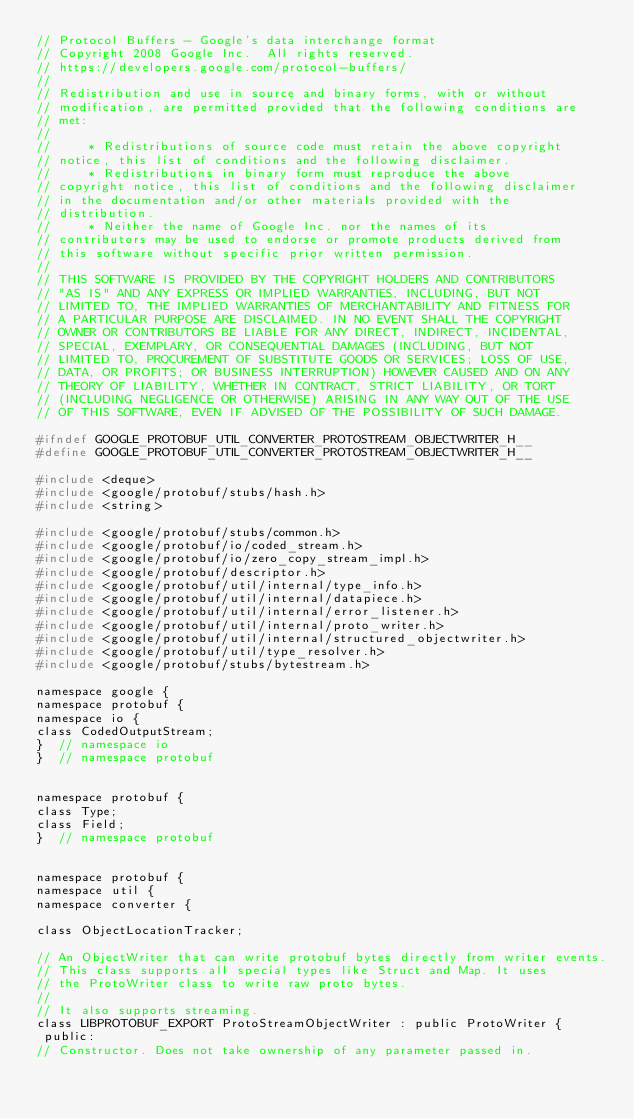Convert code to text. <code><loc_0><loc_0><loc_500><loc_500><_C_>// Protocol Buffers - Google's data interchange format
// Copyright 2008 Google Inc.  All rights reserved.
// https://developers.google.com/protocol-buffers/
//
// Redistribution and use in source and binary forms, with or without
// modification, are permitted provided that the following conditions are
// met:
//
//     * Redistributions of source code must retain the above copyright
// notice, this list of conditions and the following disclaimer.
//     * Redistributions in binary form must reproduce the above
// copyright notice, this list of conditions and the following disclaimer
// in the documentation and/or other materials provided with the
// distribution.
//     * Neither the name of Google Inc. nor the names of its
// contributors may be used to endorse or promote products derived from
// this software without specific prior written permission.
//
// THIS SOFTWARE IS PROVIDED BY THE COPYRIGHT HOLDERS AND CONTRIBUTORS
// "AS IS" AND ANY EXPRESS OR IMPLIED WARRANTIES, INCLUDING, BUT NOT
// LIMITED TO, THE IMPLIED WARRANTIES OF MERCHANTABILITY AND FITNESS FOR
// A PARTICULAR PURPOSE ARE DISCLAIMED. IN NO EVENT SHALL THE COPYRIGHT
// OWNER OR CONTRIBUTORS BE LIABLE FOR ANY DIRECT, INDIRECT, INCIDENTAL,
// SPECIAL, EXEMPLARY, OR CONSEQUENTIAL DAMAGES (INCLUDING, BUT NOT
// LIMITED TO, PROCUREMENT OF SUBSTITUTE GOODS OR SERVICES; LOSS OF USE,
// DATA, OR PROFITS; OR BUSINESS INTERRUPTION) HOWEVER CAUSED AND ON ANY
// THEORY OF LIABILITY, WHETHER IN CONTRACT, STRICT LIABILITY, OR TORT
// (INCLUDING NEGLIGENCE OR OTHERWISE) ARISING IN ANY WAY OUT OF THE USE
// OF THIS SOFTWARE, EVEN IF ADVISED OF THE POSSIBILITY OF SUCH DAMAGE.

#ifndef GOOGLE_PROTOBUF_UTIL_CONVERTER_PROTOSTREAM_OBJECTWRITER_H__
#define GOOGLE_PROTOBUF_UTIL_CONVERTER_PROTOSTREAM_OBJECTWRITER_H__

#include <deque>
#include <google/protobuf/stubs/hash.h>
#include <string>

#include <google/protobuf/stubs/common.h>
#include <google/protobuf/io/coded_stream.h>
#include <google/protobuf/io/zero_copy_stream_impl.h>
#include <google/protobuf/descriptor.h>
#include <google/protobuf/util/internal/type_info.h>
#include <google/protobuf/util/internal/datapiece.h>
#include <google/protobuf/util/internal/error_listener.h>
#include <google/protobuf/util/internal/proto_writer.h>
#include <google/protobuf/util/internal/structured_objectwriter.h>
#include <google/protobuf/util/type_resolver.h>
#include <google/protobuf/stubs/bytestream.h>

namespace google {
namespace protobuf {
namespace io {
class CodedOutputStream;
}  // namespace io
}  // namespace protobuf


namespace protobuf {
class Type;
class Field;
}  // namespace protobuf


namespace protobuf {
namespace util {
namespace converter {

class ObjectLocationTracker;

// An ObjectWriter that can write protobuf bytes directly from writer events.
// This class supports all special types like Struct and Map. It uses
// the ProtoWriter class to write raw proto bytes.
//
// It also supports streaming.
class LIBPROTOBUF_EXPORT ProtoStreamObjectWriter : public ProtoWriter {
 public:
// Constructor. Does not take ownership of any parameter passed in.</code> 